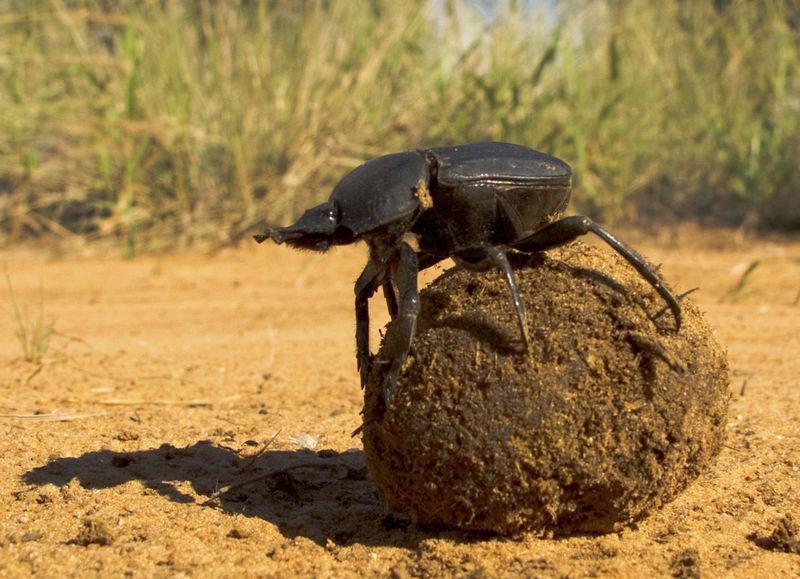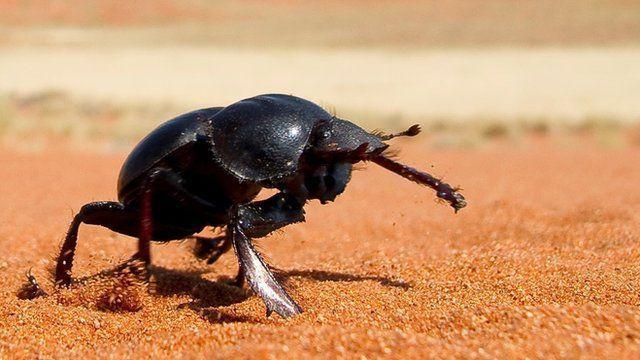The first image is the image on the left, the second image is the image on the right. For the images displayed, is the sentence "There is one beetle that is not touching a ball of dung." factually correct? Answer yes or no. Yes. 